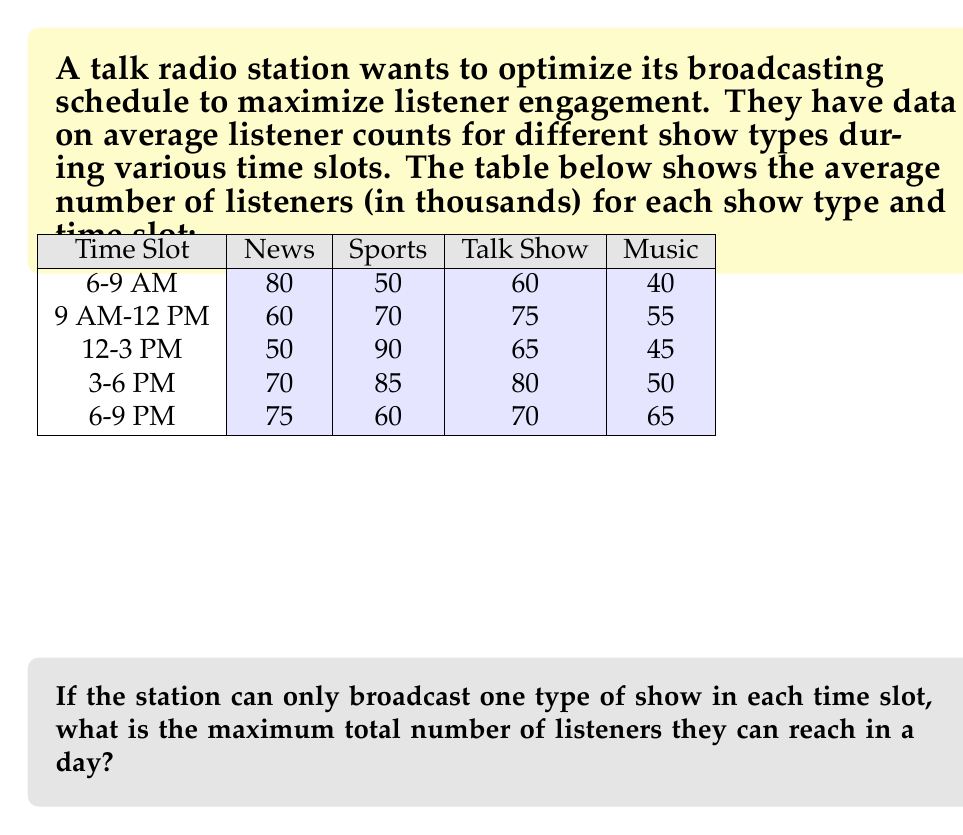Solve this math problem. To solve this optimization problem, we need to use the Hungarian algorithm (also known as the Munkres algorithm) for maximum assignment. However, we can simplify the process by following these steps:

1) For each time slot, identify the show type with the highest number of listeners:

   6-9 AM: News (80,000 listeners)
   9 AM-12 PM: Talk Show (75,000 listeners)
   12-3 PM: Sports (90,000 listeners)
   3-6 PM: Sports (85,000 listeners)
   6-9 PM: News (75,000 listeners)

2) Sum up the maximum values for each time slot:

   $$80,000 + 75,000 + 90,000 + 85,000 + 75,000 = 405,000$$

3) This assignment ensures that each time slot has the show type that maximizes listeners for that particular slot, and no show type is used more than once (which satisfies the constraint of broadcasting only one type of show in each time slot).

4) Therefore, the maximum total number of listeners they can reach in a day is 405,000.

Note: This greedy approach works in this case because we have the same number of time slots as show types, and each slot is independent. For more complex scenarios with additional constraints, more advanced optimization techniques might be necessary.
Answer: 405,000 listeners 